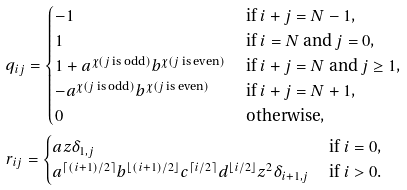<formula> <loc_0><loc_0><loc_500><loc_500>& q _ { i j } = \begin{cases} - 1 & \text { if $i+j=N-1$,} \\ 1 & \text { if $i=N$ and $j=0$,} \\ 1 + a ^ { \chi ( \text {$j$ is odd} ) } b ^ { \chi ( \text {$j$ is even} ) } & \text { if $i+j=N$ and $j\geq1$,} \\ - a ^ { \chi ( \text {$j$ is odd} ) } b ^ { \chi ( \text {$j$ is even} ) } & \text { if $i+j=N+1$,} \\ 0 & \text { otherwise,} \end{cases} \\ & r _ { i j } = \begin{cases} a z \delta _ { 1 , j } & \text { if $i=0$,} \\ a ^ { \lceil ( i + 1 ) / 2 \rceil } b ^ { \lfloor ( i + 1 ) / 2 \rfloor } c ^ { \lceil i / 2 \rceil } d ^ { \lfloor i / 2 \rfloor } z ^ { 2 } \delta _ { i + 1 , j } & \text { if $i>0$.} \end{cases}</formula> 